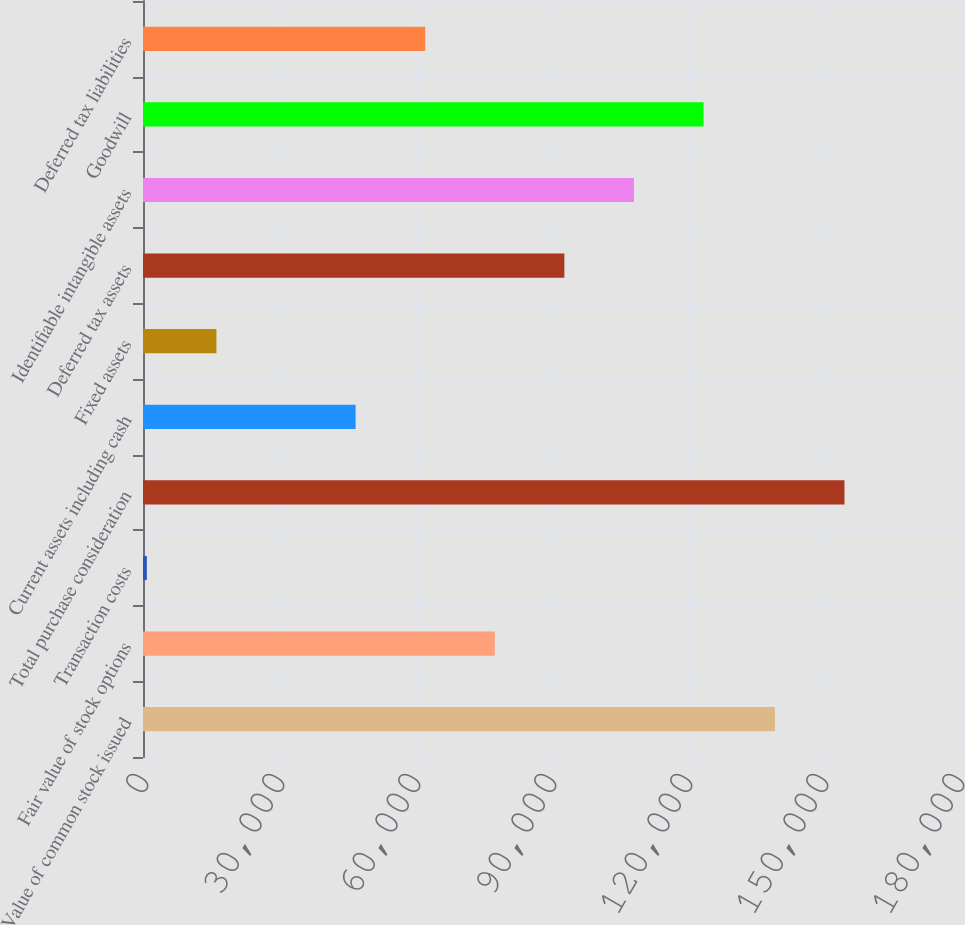Convert chart to OTSL. <chart><loc_0><loc_0><loc_500><loc_500><bar_chart><fcel>Value of common stock issued<fcel>Fair value of stock options<fcel>Transaction costs<fcel>Total purchase consideration<fcel>Current assets including cash<fcel>Fixed assets<fcel>Deferred tax assets<fcel>Identifiable intangible assets<fcel>Goodwill<fcel>Deferred tax liabilities<nl><fcel>139387<fcel>77599<fcel>847<fcel>154737<fcel>46898.2<fcel>16197.4<fcel>92949.4<fcel>108300<fcel>123650<fcel>62248.6<nl></chart> 